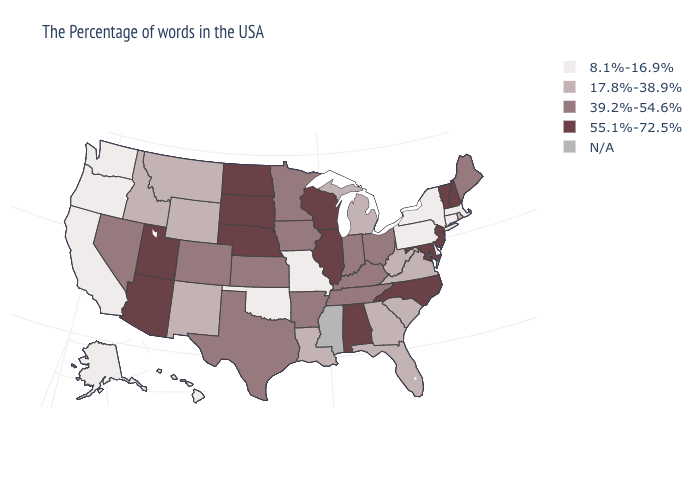What is the value of New Jersey?
Short answer required. 55.1%-72.5%. What is the value of New Mexico?
Write a very short answer. 17.8%-38.9%. Name the states that have a value in the range 39.2%-54.6%?
Be succinct. Maine, Ohio, Kentucky, Indiana, Tennessee, Arkansas, Minnesota, Iowa, Kansas, Texas, Colorado, Nevada. Among the states that border Texas , does Oklahoma have the lowest value?
Concise answer only. Yes. Does Vermont have the lowest value in the USA?
Answer briefly. No. What is the lowest value in states that border Kentucky?
Quick response, please. 8.1%-16.9%. What is the highest value in the USA?
Write a very short answer. 55.1%-72.5%. What is the value of Alabama?
Answer briefly. 55.1%-72.5%. How many symbols are there in the legend?
Concise answer only. 5. What is the lowest value in states that border New York?
Quick response, please. 8.1%-16.9%. Does New Hampshire have the highest value in the Northeast?
Give a very brief answer. Yes. Name the states that have a value in the range N/A?
Answer briefly. Mississippi. 